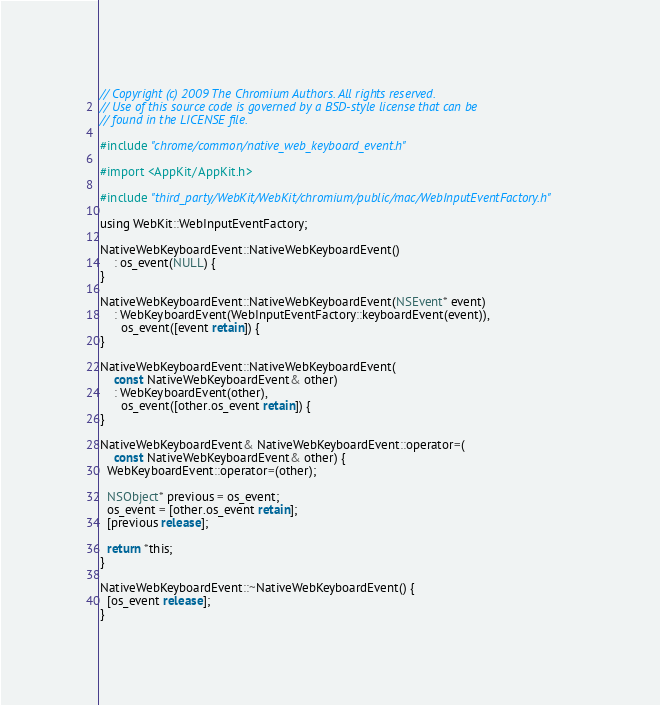Convert code to text. <code><loc_0><loc_0><loc_500><loc_500><_ObjectiveC_>// Copyright (c) 2009 The Chromium Authors. All rights reserved.
// Use of this source code is governed by a BSD-style license that can be
// found in the LICENSE file.

#include "chrome/common/native_web_keyboard_event.h"

#import <AppKit/AppKit.h>

#include "third_party/WebKit/WebKit/chromium/public/mac/WebInputEventFactory.h"

using WebKit::WebInputEventFactory;

NativeWebKeyboardEvent::NativeWebKeyboardEvent()
    : os_event(NULL) {
}

NativeWebKeyboardEvent::NativeWebKeyboardEvent(NSEvent* event)
    : WebKeyboardEvent(WebInputEventFactory::keyboardEvent(event)),
      os_event([event retain]) {
}

NativeWebKeyboardEvent::NativeWebKeyboardEvent(
    const NativeWebKeyboardEvent& other)
    : WebKeyboardEvent(other),
      os_event([other.os_event retain]) {
}

NativeWebKeyboardEvent& NativeWebKeyboardEvent::operator=(
    const NativeWebKeyboardEvent& other) {
  WebKeyboardEvent::operator=(other);

  NSObject* previous = os_event;
  os_event = [other.os_event retain];
  [previous release];

  return *this;
}

NativeWebKeyboardEvent::~NativeWebKeyboardEvent() {
  [os_event release];
}
</code> 